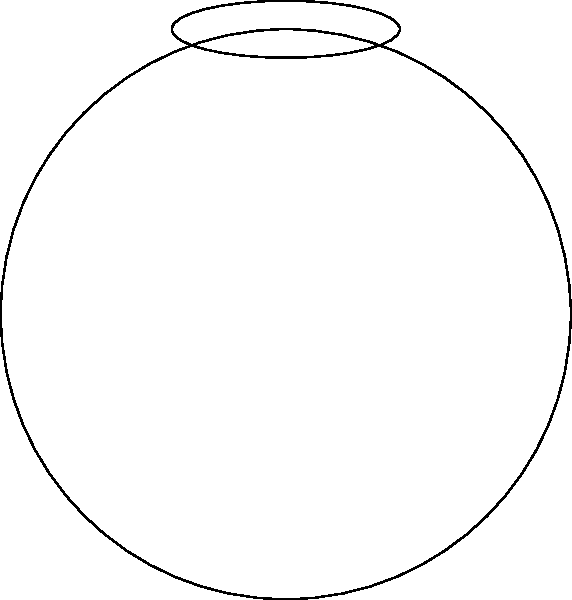Calculate the total surface area of a spherical satellite with three protruding elliptical antenna dishes. The satellite's main body has a radius of 5 meters. Each antenna dish is an ellipse with a semi-major axis of 2 meters and a semi-minor axis of 0.5 meters. Assume the dishes are flat and mounted directly on the surface of the sphere. Let's break this down step-by-step:

1) First, calculate the surface area of the main spherical body:
   $$A_{sphere} = 4\pi r^2 = 4\pi (5^2) = 100\pi \text{ m}^2$$

2) Now, calculate the area of one elliptical antenna dish:
   $$A_{ellipse} = \pi ab = \pi(2)(0.5) = \pi \text{ m}^2$$

3) There are three antenna dishes, so the total area of the dishes is:
   $$A_{dishes} = 3\pi \text{ m}^2$$

4) However, these dishes are mounted on the sphere, so we need to subtract the area they cover on the sphere:
   $$A_{covered} = 3\pi \text{ m}^2$$

5) The total surface area is therefore:
   $$A_{total} = A_{sphere} + A_{dishes} - A_{covered}$$
   $$A_{total} = 100\pi + 3\pi - 3\pi = 100\pi \text{ m}^2$$

Therefore, the total surface area of the satellite is $100\pi$ square meters.
Answer: $100\pi \text{ m}^2$ 